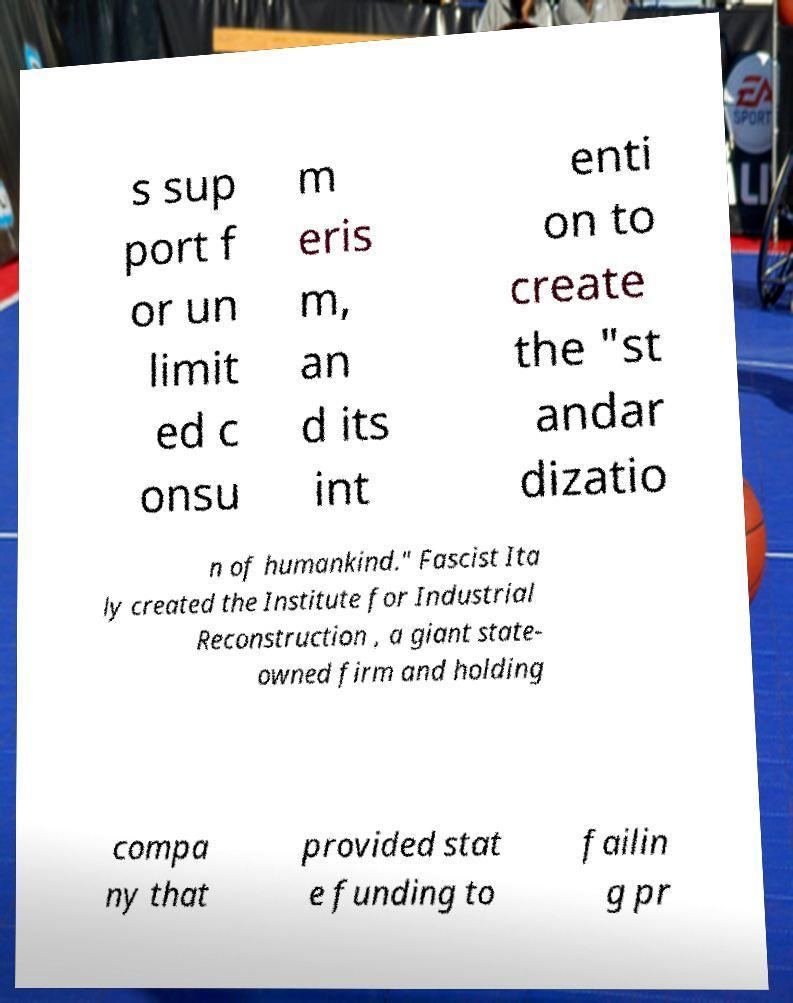There's text embedded in this image that I need extracted. Can you transcribe it verbatim? s sup port f or un limit ed c onsu m eris m, an d its int enti on to create the "st andar dizatio n of humankind." Fascist Ita ly created the Institute for Industrial Reconstruction , a giant state- owned firm and holding compa ny that provided stat e funding to failin g pr 